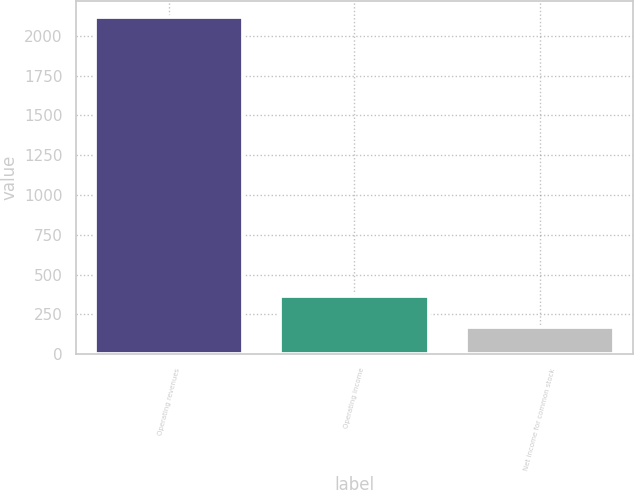<chart> <loc_0><loc_0><loc_500><loc_500><bar_chart><fcel>Operating revenues<fcel>Operating income<fcel>Net income for common stock<nl><fcel>2116<fcel>363.7<fcel>169<nl></chart> 